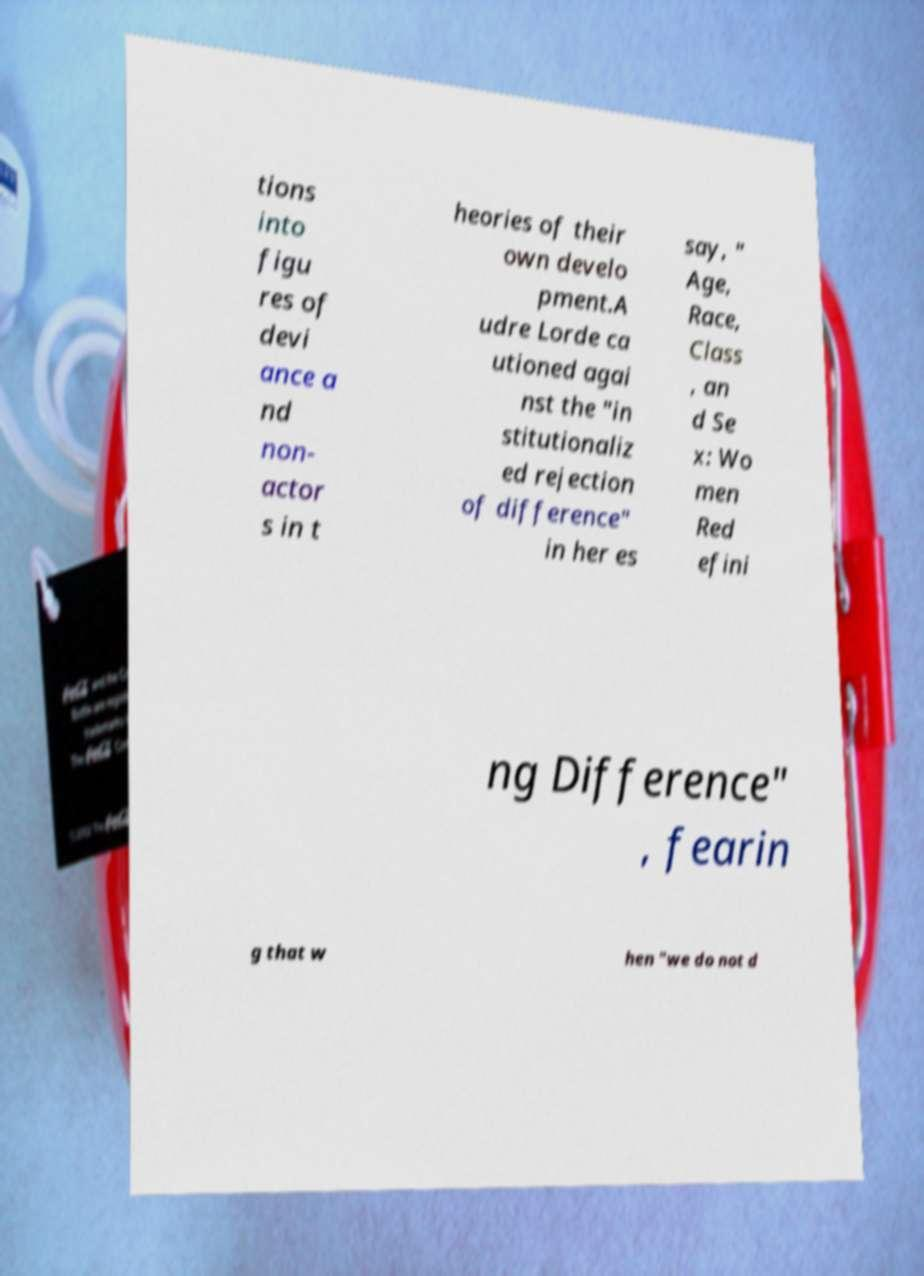Could you assist in decoding the text presented in this image and type it out clearly? tions into figu res of devi ance a nd non- actor s in t heories of their own develo pment.A udre Lorde ca utioned agai nst the "in stitutionaliz ed rejection of difference" in her es say, " Age, Race, Class , an d Se x: Wo men Red efini ng Difference" , fearin g that w hen "we do not d 